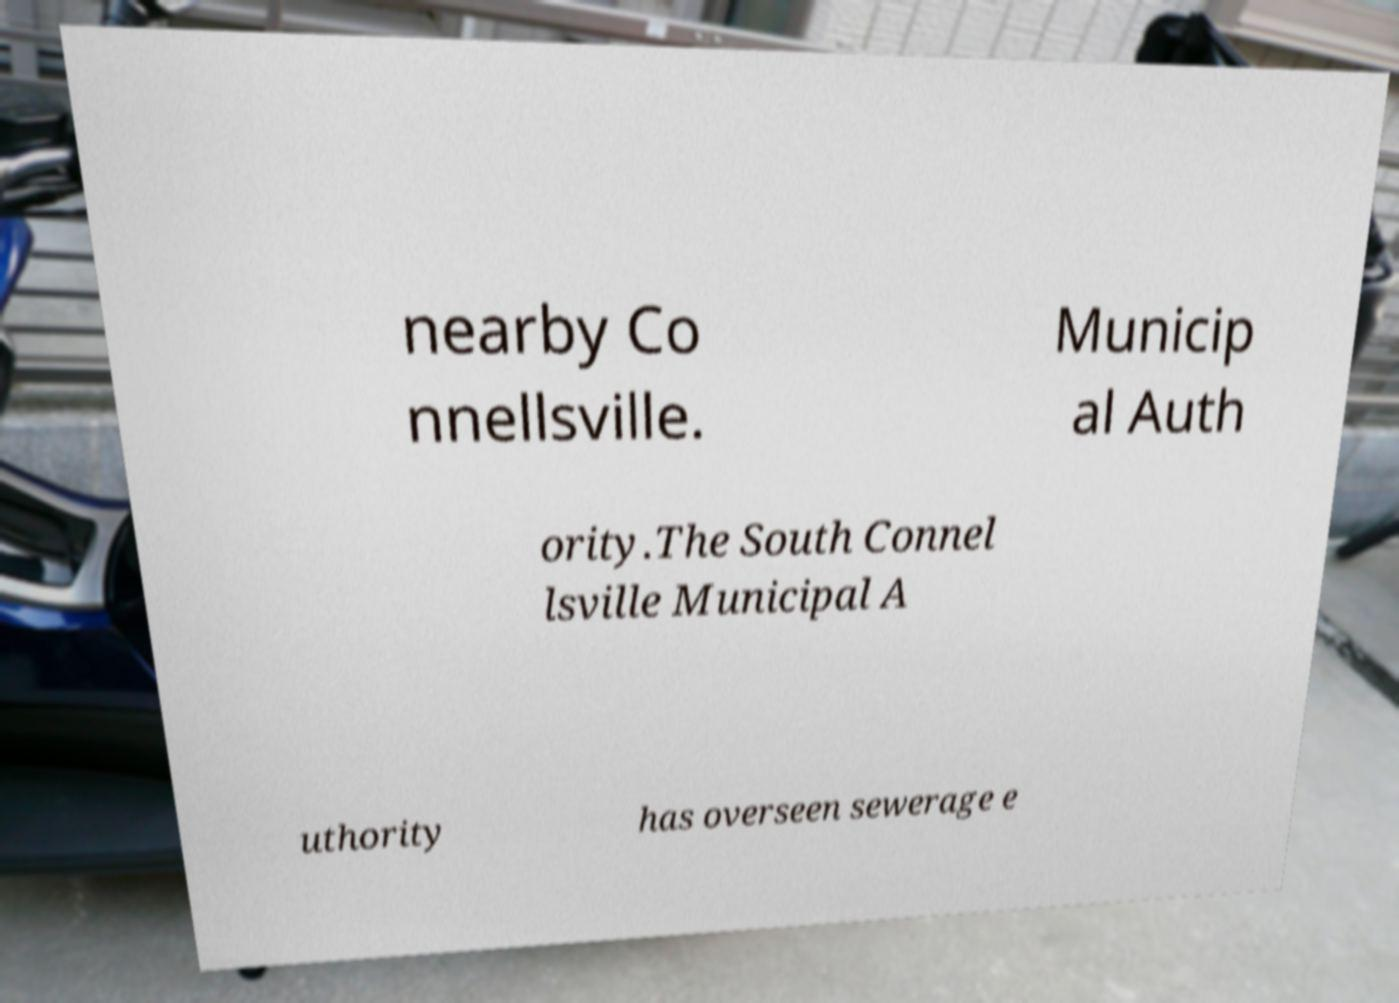I need the written content from this picture converted into text. Can you do that? nearby Co nnellsville. Municip al Auth ority.The South Connel lsville Municipal A uthority has overseen sewerage e 